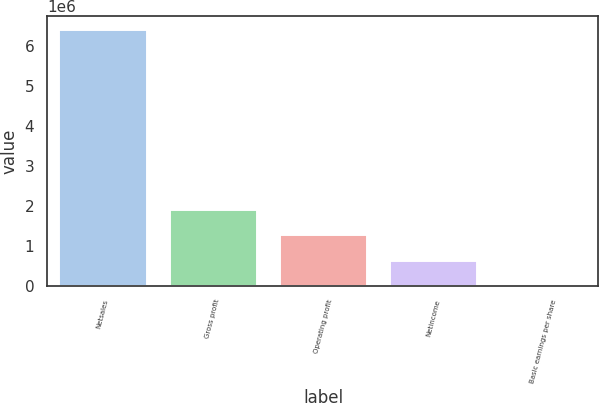Convert chart. <chart><loc_0><loc_0><loc_500><loc_500><bar_chart><fcel>Netsales<fcel>Gross profit<fcel>Operating profit<fcel>Netincome<fcel>Basic earnings per share<nl><fcel>6.41746e+06<fcel>1.92524e+06<fcel>1.28349e+06<fcel>641747<fcel>1.26<nl></chart> 